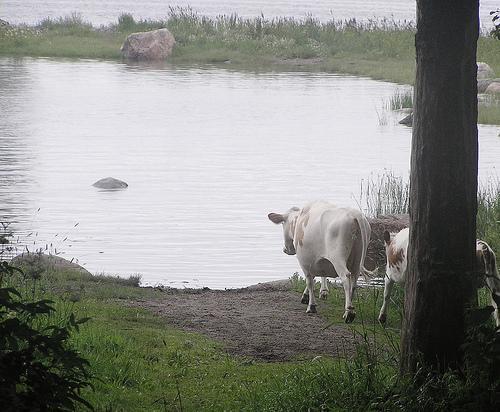How many cows are visible?
Give a very brief answer. 2. 